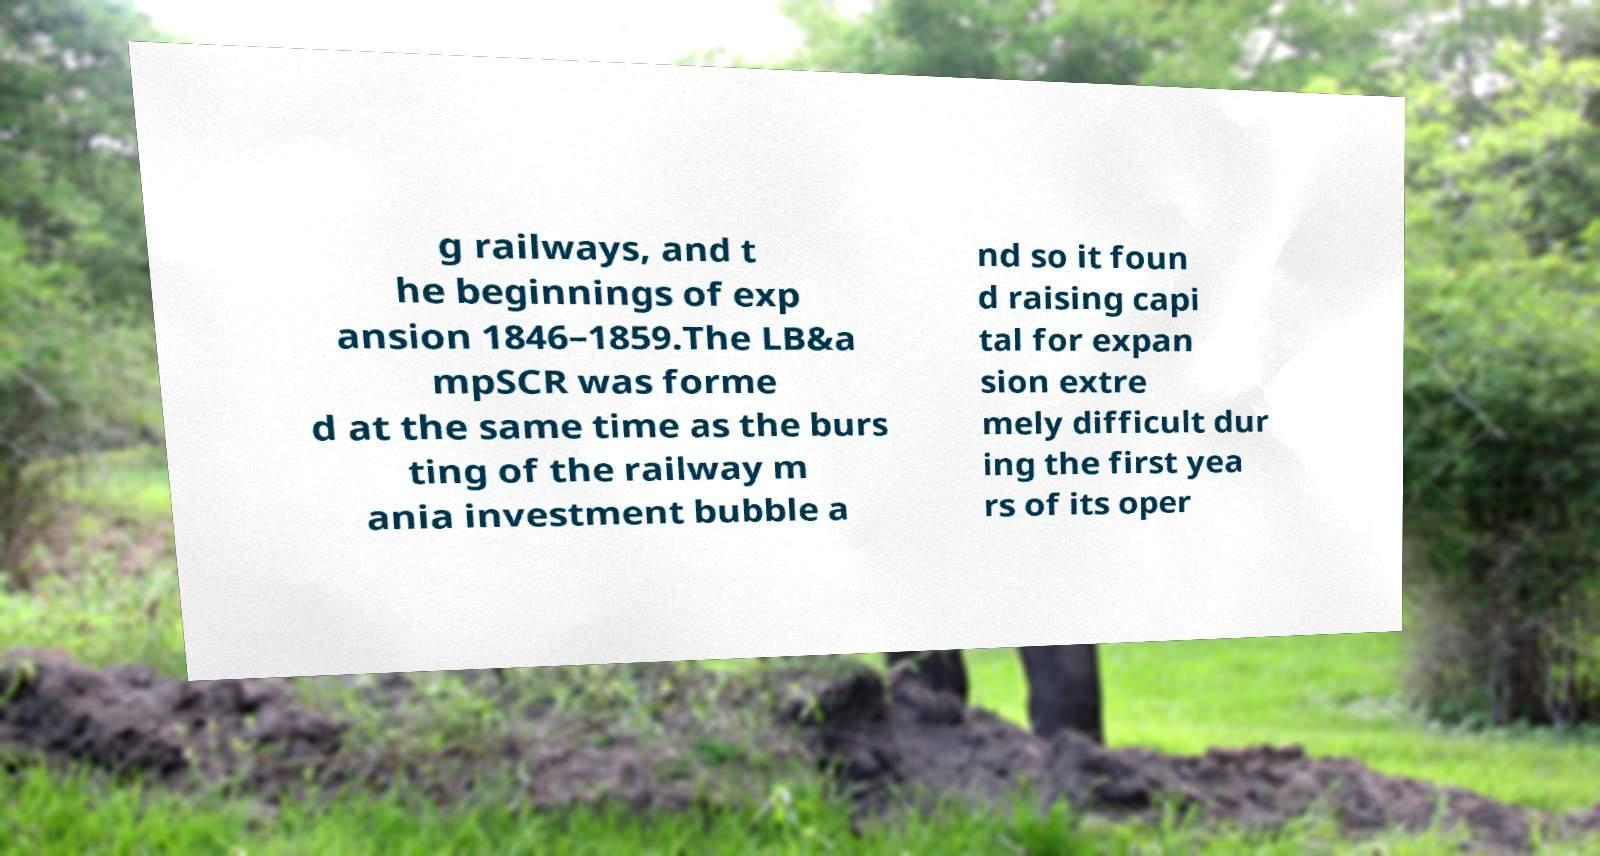Can you accurately transcribe the text from the provided image for me? g railways, and t he beginnings of exp ansion 1846–1859.The LB&a mpSCR was forme d at the same time as the burs ting of the railway m ania investment bubble a nd so it foun d raising capi tal for expan sion extre mely difficult dur ing the first yea rs of its oper 